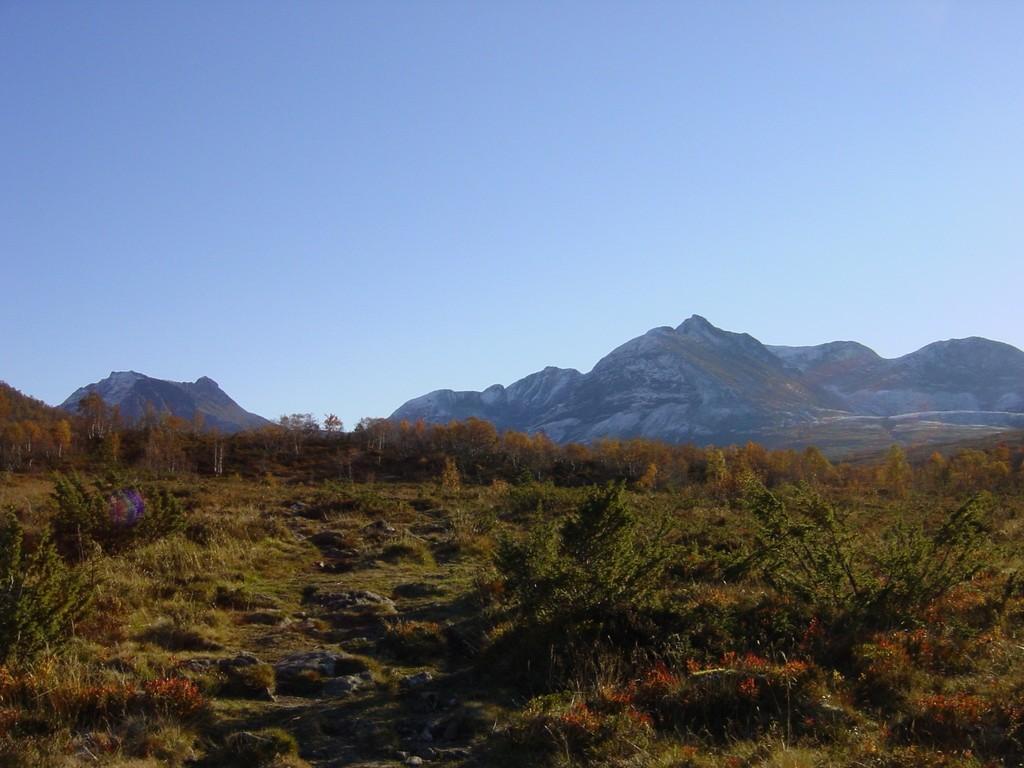In one or two sentences, can you explain what this image depicts? In the picture we can see a grass surface with some plants on it and in the background, we can see trees and behind it we can see some hills and sky. 